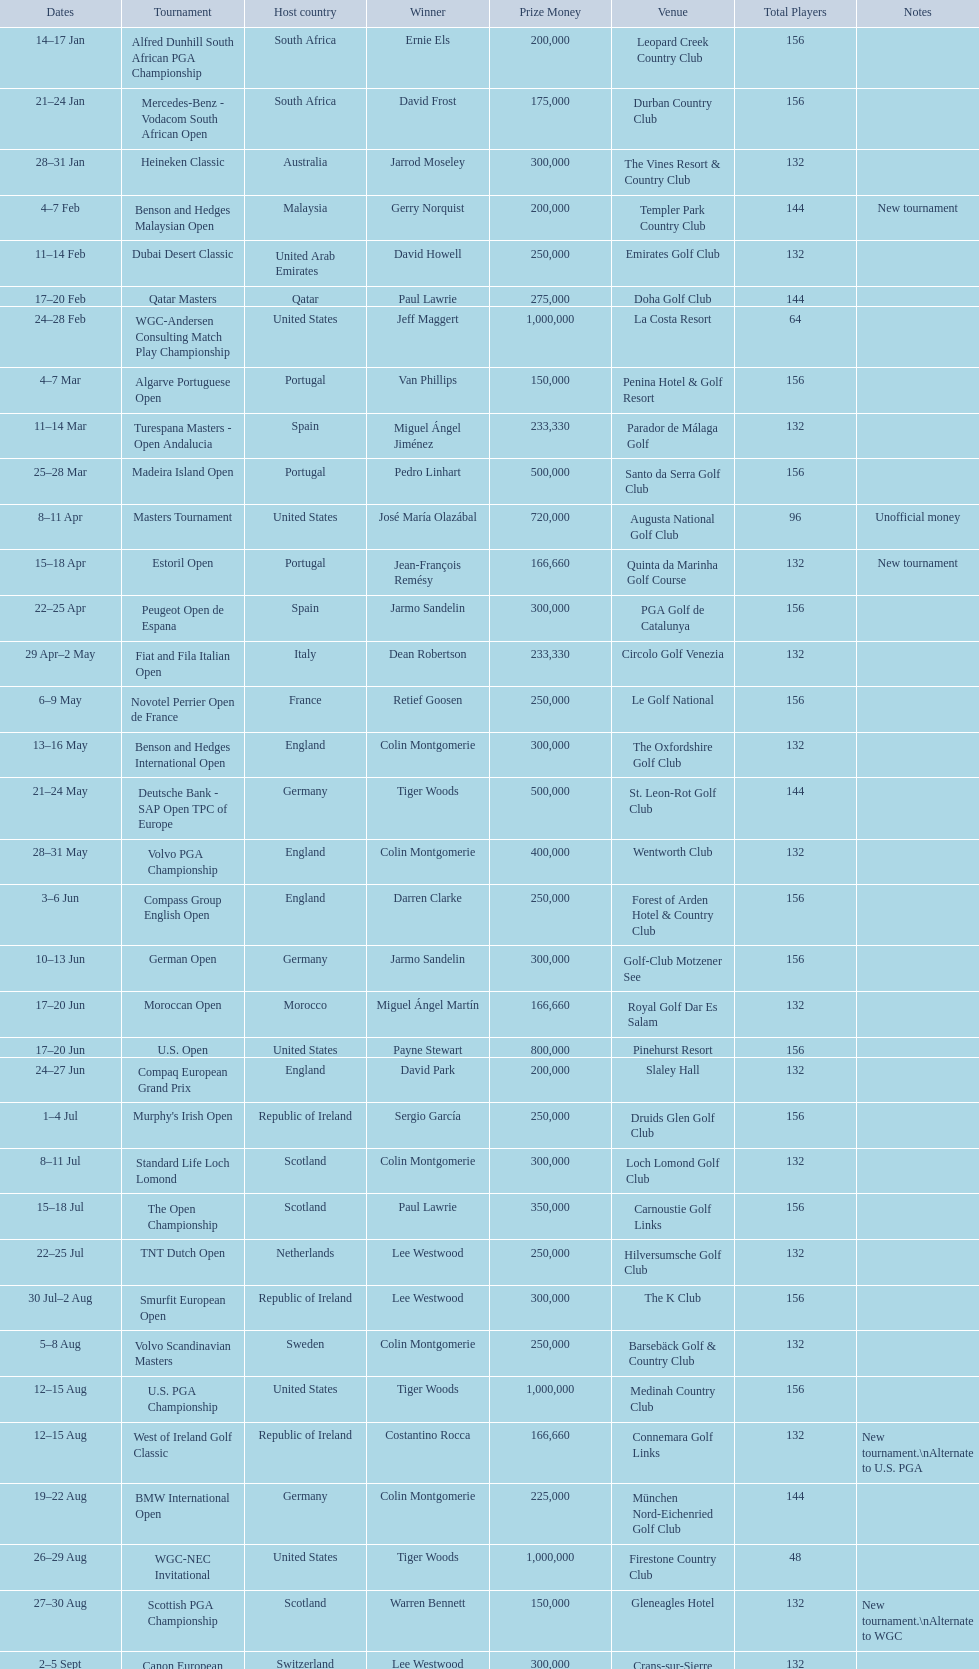How many consecutive times was south africa the host country? 2. 